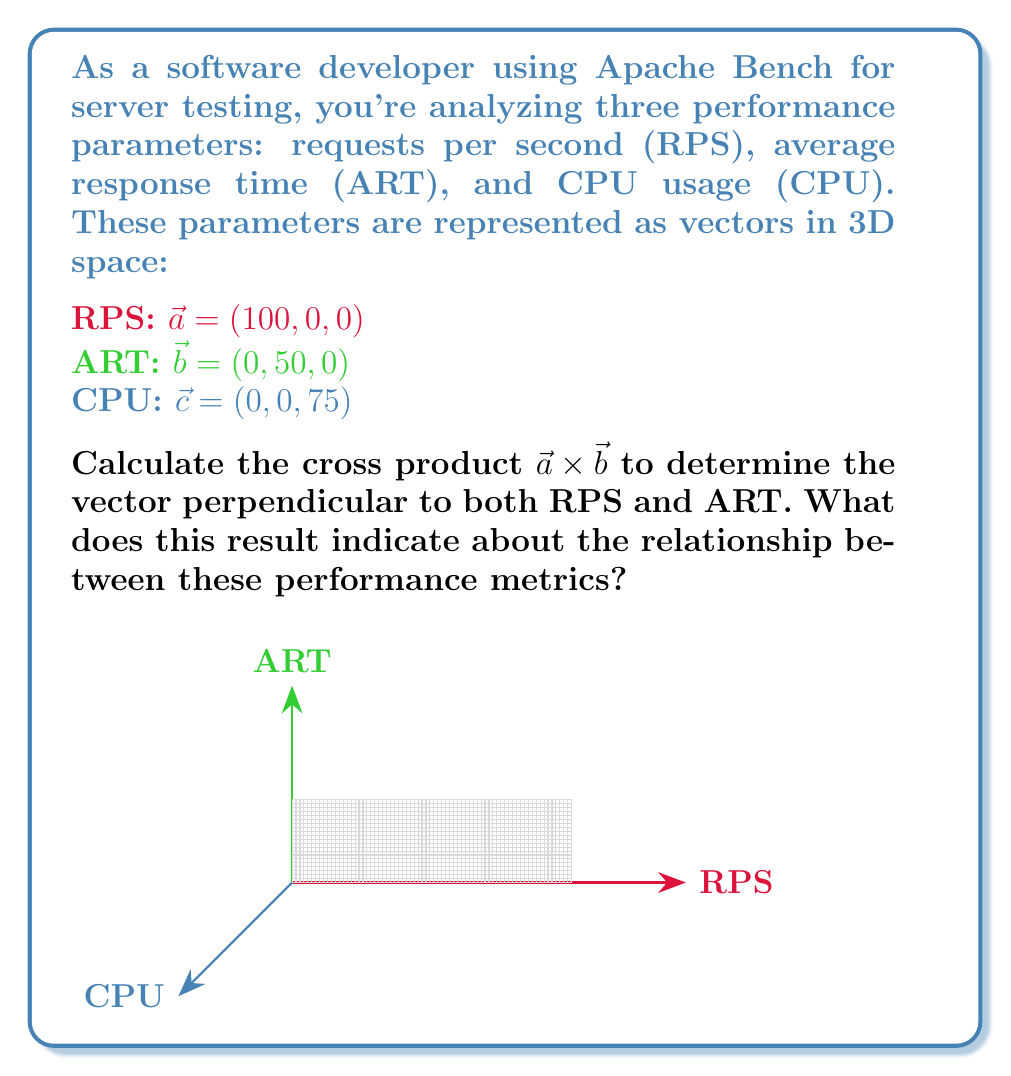Give your solution to this math problem. To compute the cross product $\vec{a} \times \vec{b}$, we use the formula:

$$\vec{a} \times \vec{b} = (a_y b_z - a_z b_y, a_z b_x - a_x b_z, a_x b_y - a_y b_x)$$

Given:
$\vec{a} = (100, 0, 0)$
$\vec{b} = (0, 50, 0)$

Step 1: Calculate each component:
1. $a_y b_z - a_z b_y = 0 \cdot 0 - 0 \cdot 50 = 0$
2. $a_z b_x - a_x b_z = 0 \cdot 0 - 100 \cdot 0 = 0$
3. $a_x b_y - a_y b_x = 100 \cdot 50 - 0 \cdot 0 = 5000$

Step 2: Combine the results:
$\vec{a} \times \vec{b} = (0, 0, 5000)$

The resulting vector is perpendicular to both RPS and ART, pointing along the CPU axis. This indicates that:

1. The magnitude (5000) represents the area of the parallelogram formed by RPS and ART vectors.
2. The direction (along the CPU axis) suggests that changes in RPS and ART may impact CPU usage.
3. The perpendicular nature implies that RPS and ART are independent metrics in this representation.

This cross product can help in analyzing the relationship between different performance parameters and potentially identify correlations or trade-offs in server performance.
Answer: $\vec{a} \times \vec{b} = (0, 0, 5000)$ 